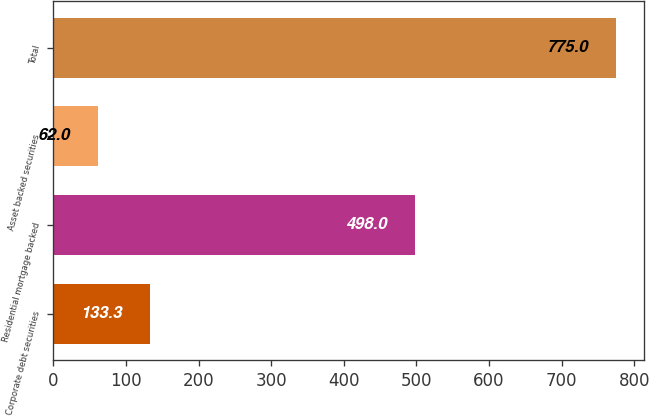<chart> <loc_0><loc_0><loc_500><loc_500><bar_chart><fcel>Corporate debt securities<fcel>Residential mortgage backed<fcel>Asset backed securities<fcel>Total<nl><fcel>133.3<fcel>498<fcel>62<fcel>775<nl></chart> 